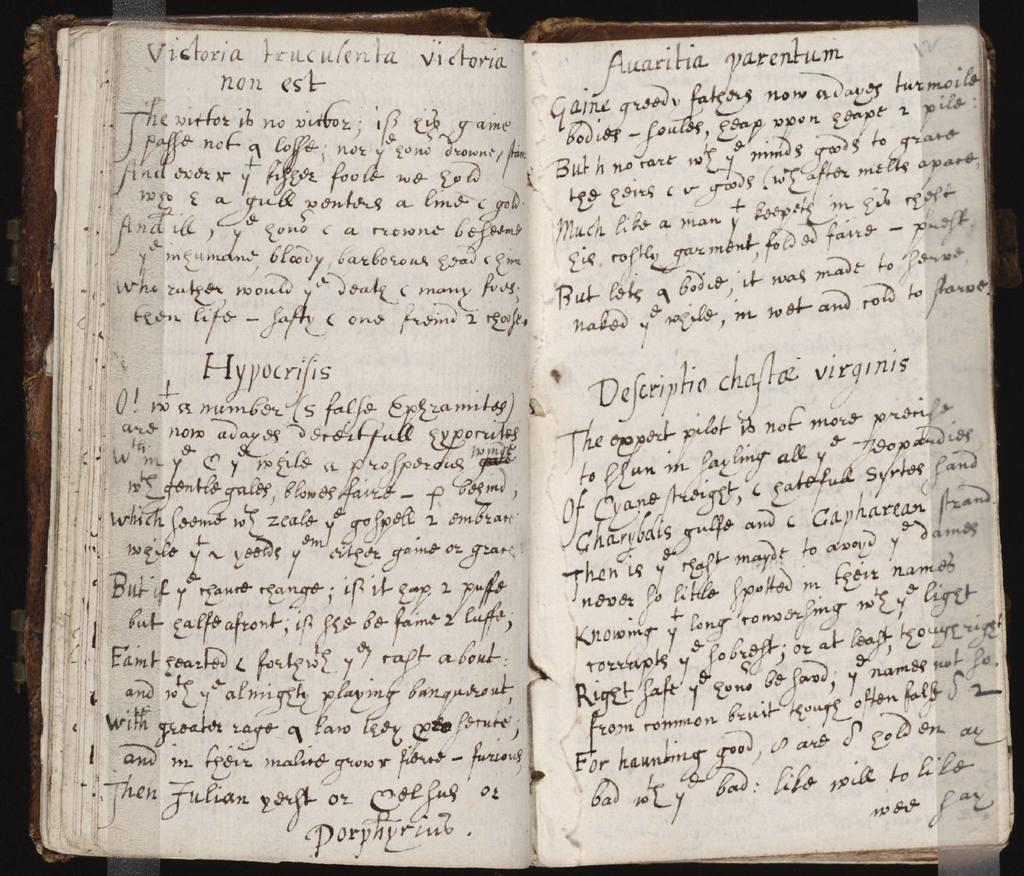<image>
Describe the image concisely. A book is open to show hand written pages and the section hypocrifis/ 